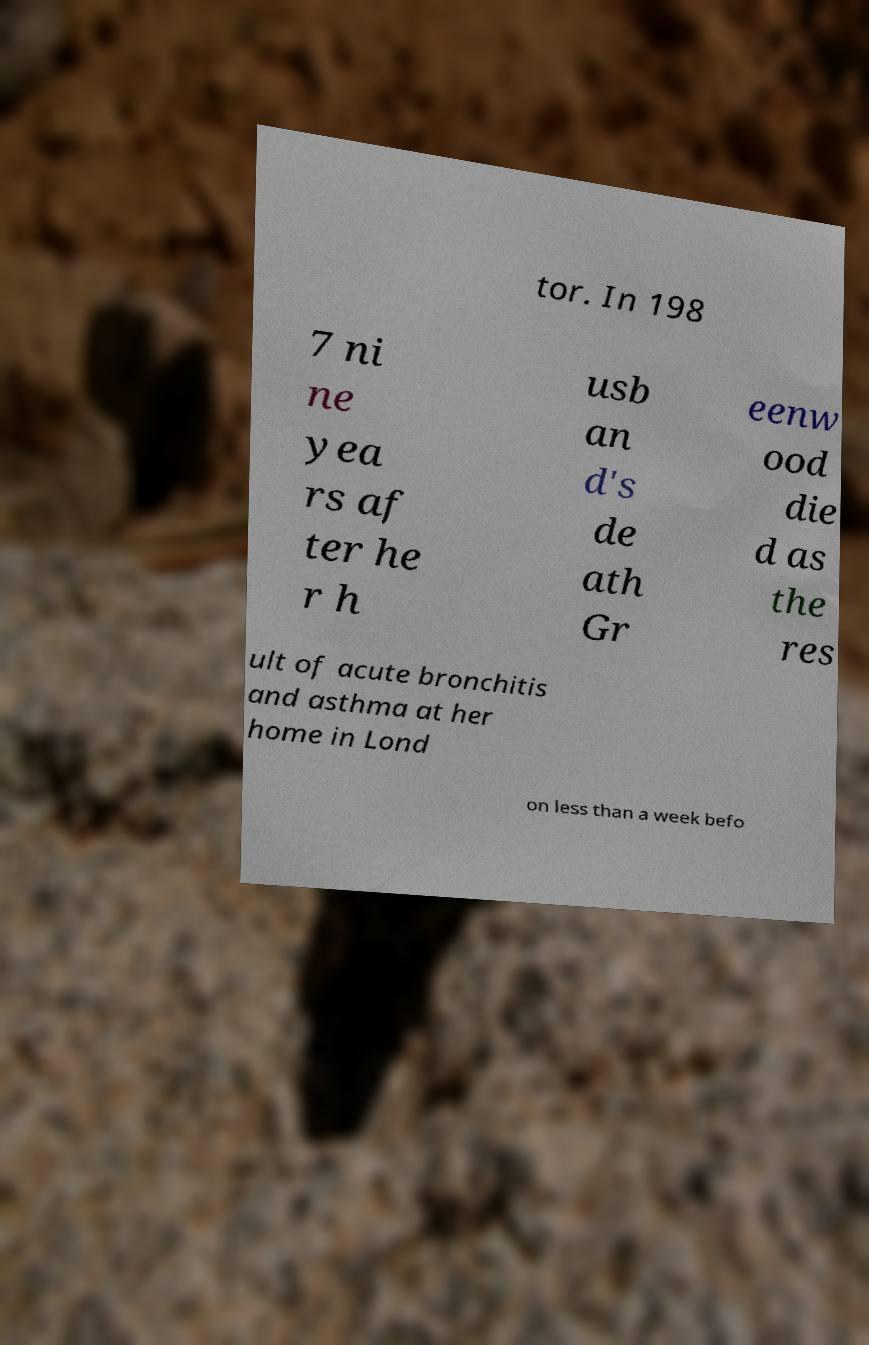Could you assist in decoding the text presented in this image and type it out clearly? tor. In 198 7 ni ne yea rs af ter he r h usb an d's de ath Gr eenw ood die d as the res ult of acute bronchitis and asthma at her home in Lond on less than a week befo 